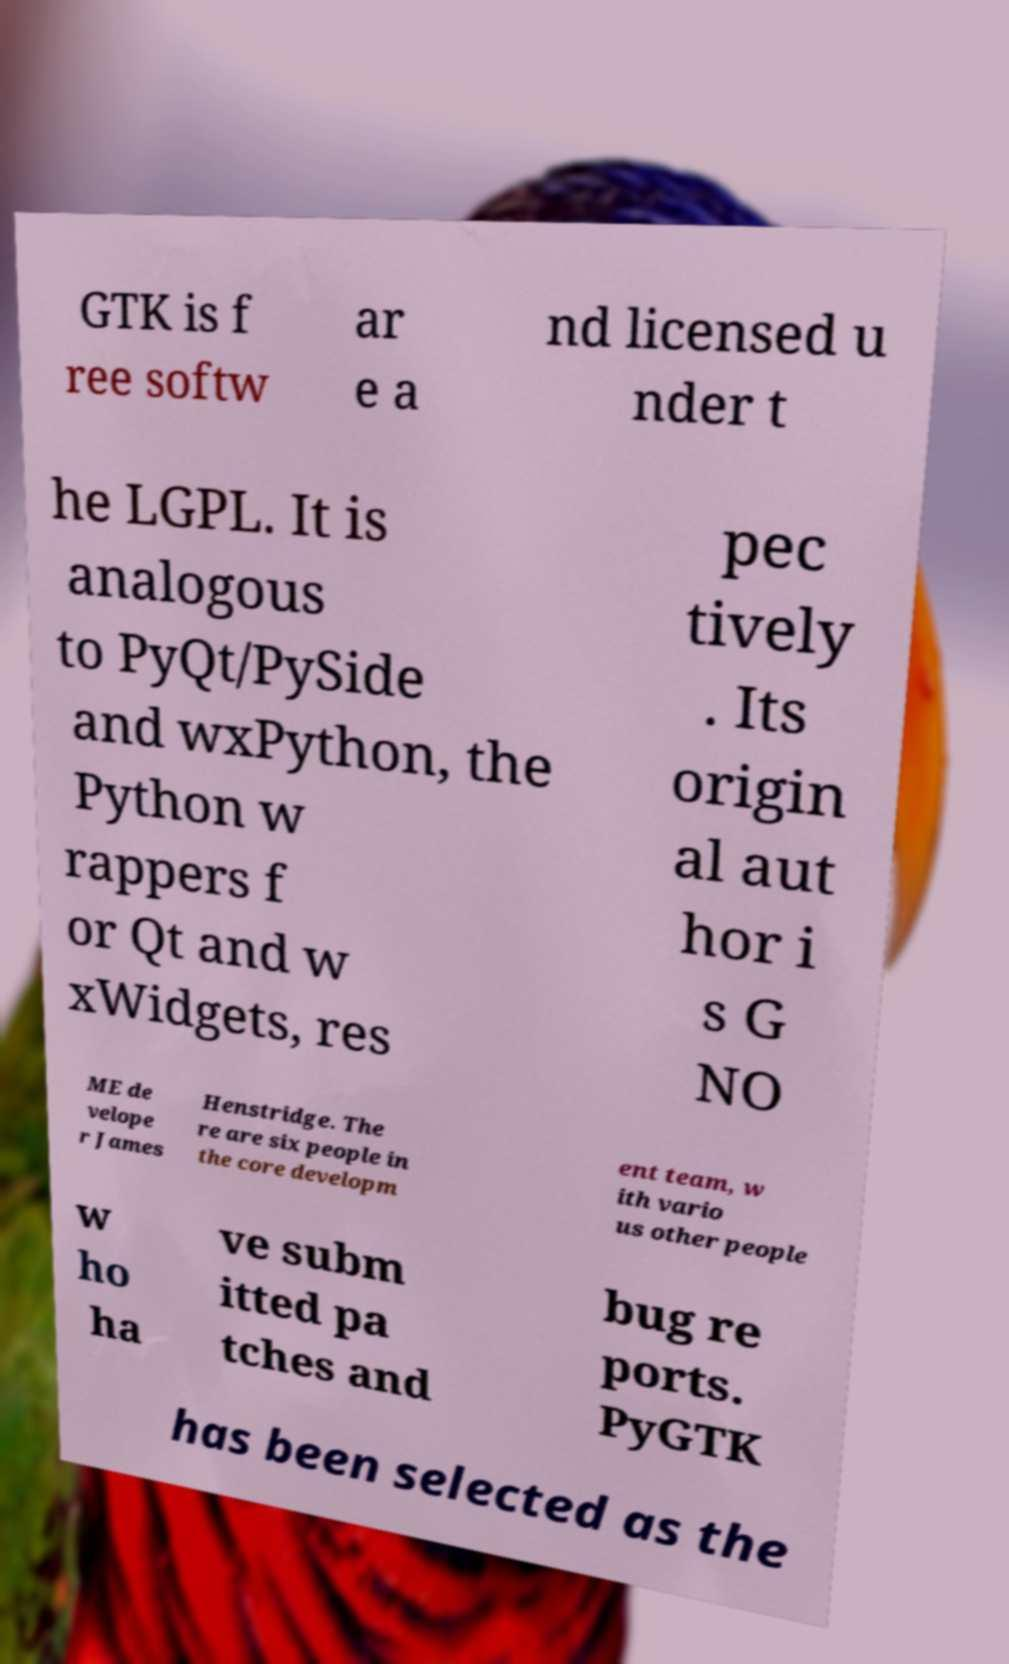Can you accurately transcribe the text from the provided image for me? GTK is f ree softw ar e a nd licensed u nder t he LGPL. It is analogous to PyQt/PySide and wxPython, the Python w rappers f or Qt and w xWidgets, res pec tively . Its origin al aut hor i s G NO ME de velope r James Henstridge. The re are six people in the core developm ent team, w ith vario us other people w ho ha ve subm itted pa tches and bug re ports. PyGTK has been selected as the 